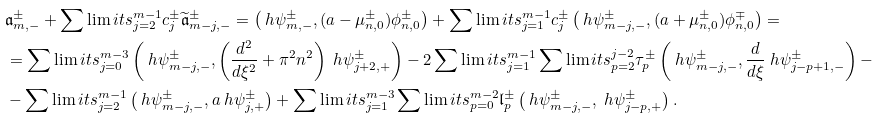Convert formula to latex. <formula><loc_0><loc_0><loc_500><loc_500>& \mathfrak { a } _ { m , - } ^ { \pm } + \sum \lim i t s _ { j = 2 } ^ { m - 1 } c _ { j } ^ { \pm } \widetilde { \mathfrak { a } } _ { m - j , - } ^ { \pm } = \left ( \ h \psi _ { m , - } ^ { \pm } , ( a - \mu _ { n , 0 } ^ { \pm } ) \phi _ { n , 0 } ^ { \pm } \right ) + \sum \lim i t s _ { j = 1 } ^ { m - 1 } c _ { j } ^ { \pm } \left ( \ h \psi _ { m - j , - } ^ { \pm } , ( a + \mu _ { n , 0 } ^ { \pm } ) \phi _ { n , 0 } ^ { \mp } \right ) = \\ & = \sum \lim i t s _ { j = 0 } ^ { m - 3 } \left ( \ h \psi _ { m - j , - } ^ { \pm } , \left ( \frac { d ^ { 2 } } { d \xi ^ { 2 } } + \pi ^ { 2 } n ^ { 2 } \right ) \ h \psi _ { j + 2 , + } ^ { \pm } \right ) - 2 \sum \lim i t s _ { j = 1 } ^ { m - 1 } \sum \lim i t s _ { p = 2 } ^ { j - 2 } \tau _ { p } ^ { \pm } \left ( \ h \psi _ { m - j , - } ^ { \pm } , \frac { d } { d \xi } \ h \psi _ { j - p + 1 , - } ^ { \pm } \right ) - \\ & - \sum \lim i t s _ { j = 2 } ^ { m - 1 } \left ( \ h \psi _ { m - j , - } ^ { \pm } , a \ h \psi _ { j , + } ^ { \pm } \right ) + \sum \lim i t s _ { j = 1 } ^ { m - 3 } \sum \lim i t s _ { p = 0 } ^ { m - 2 } \mathfrak { l } _ { p } ^ { \pm } \left ( \ h \psi _ { m - j , - } ^ { \pm } , \ h \psi _ { j - p , + } ^ { \pm } \right ) .</formula> 